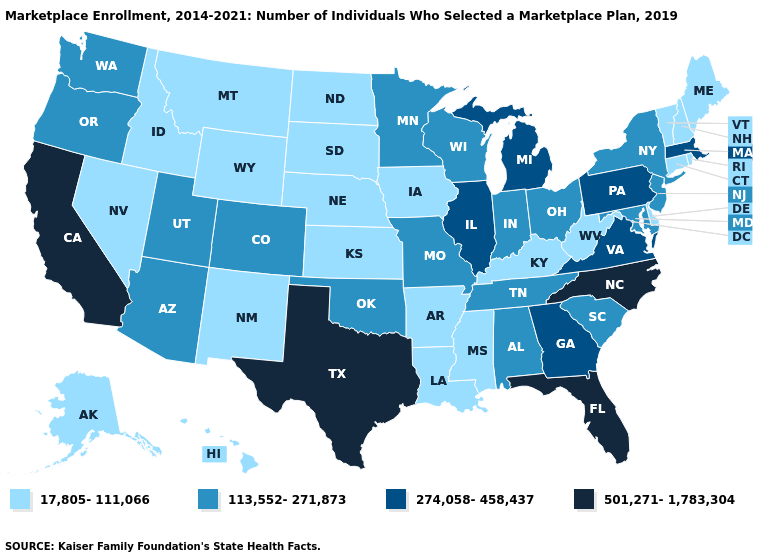Does Mississippi have the lowest value in the USA?
Keep it brief. Yes. Name the states that have a value in the range 501,271-1,783,304?
Quick response, please. California, Florida, North Carolina, Texas. What is the value of Nebraska?
Short answer required. 17,805-111,066. Does Pennsylvania have a higher value than California?
Write a very short answer. No. What is the value of Oregon?
Short answer required. 113,552-271,873. Which states have the highest value in the USA?
Quick response, please. California, Florida, North Carolina, Texas. What is the lowest value in the USA?
Short answer required. 17,805-111,066. What is the value of Colorado?
Give a very brief answer. 113,552-271,873. Does Michigan have a higher value than Minnesota?
Give a very brief answer. Yes. What is the highest value in states that border South Dakota?
Answer briefly. 113,552-271,873. What is the value of Oklahoma?
Keep it brief. 113,552-271,873. Name the states that have a value in the range 113,552-271,873?
Write a very short answer. Alabama, Arizona, Colorado, Indiana, Maryland, Minnesota, Missouri, New Jersey, New York, Ohio, Oklahoma, Oregon, South Carolina, Tennessee, Utah, Washington, Wisconsin. Name the states that have a value in the range 501,271-1,783,304?
Be succinct. California, Florida, North Carolina, Texas. Does New York have the lowest value in the USA?
Answer briefly. No. 